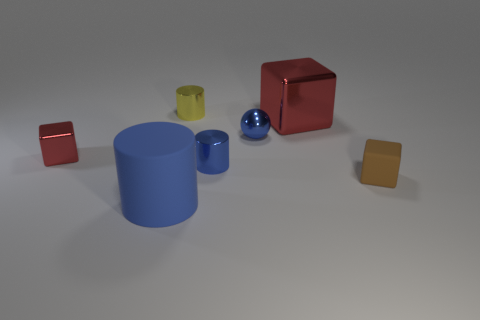What number of small things are either brown cylinders or metal cubes?
Offer a very short reply. 1. Are any big gray cylinders visible?
Provide a succinct answer. No. What size is the other cube that is made of the same material as the tiny red block?
Offer a terse response. Large. Is the material of the big blue cylinder the same as the yellow cylinder?
Give a very brief answer. No. What number of other things are there of the same material as the small red cube
Ensure brevity in your answer.  4. How many large objects are to the left of the tiny blue sphere and behind the small brown block?
Keep it short and to the point. 0. The ball is what color?
Your answer should be compact. Blue. There is a tiny red thing that is the same shape as the small brown matte object; what material is it?
Ensure brevity in your answer.  Metal. Is there anything else that has the same material as the brown block?
Make the answer very short. Yes. Is the big rubber thing the same color as the shiny sphere?
Give a very brief answer. Yes. 